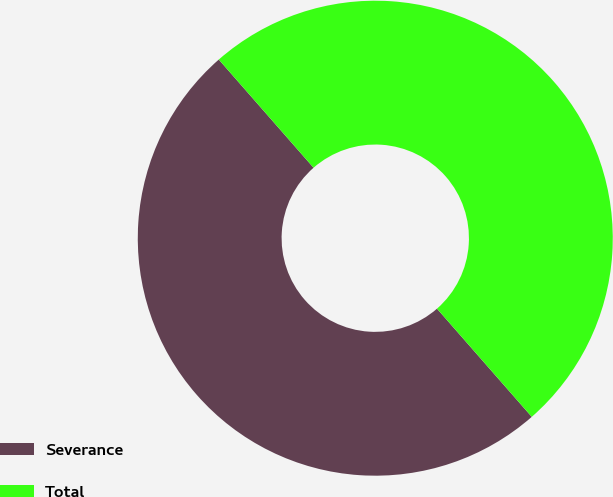Convert chart. <chart><loc_0><loc_0><loc_500><loc_500><pie_chart><fcel>Severance<fcel>Total<nl><fcel>50.0%<fcel>50.0%<nl></chart> 